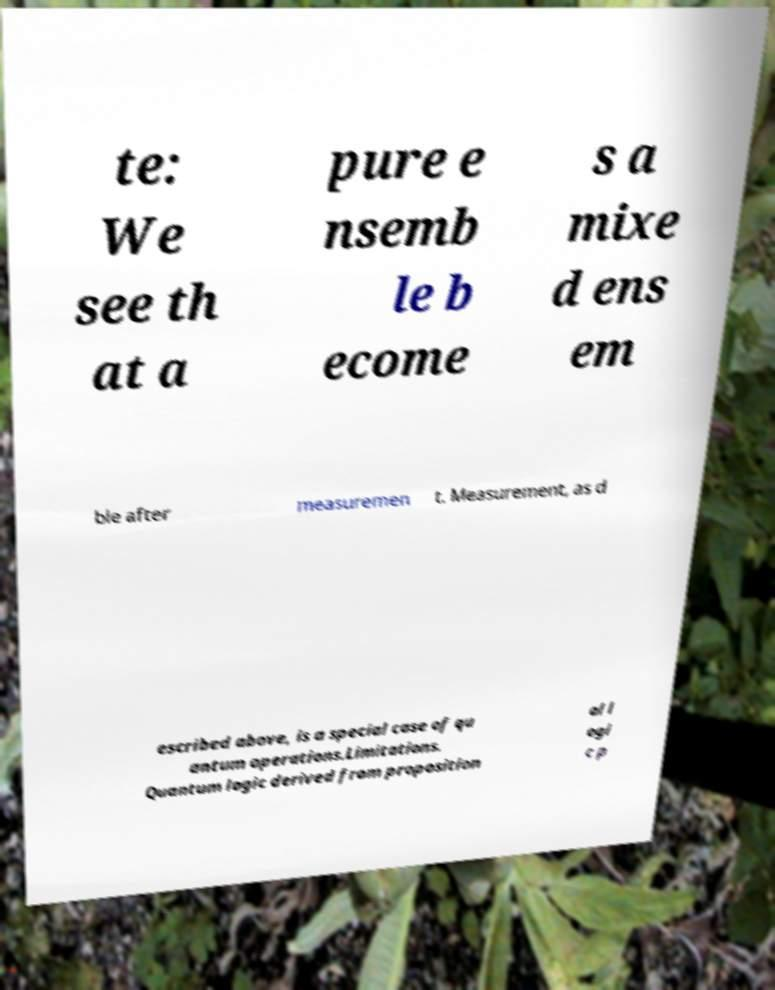Could you extract and type out the text from this image? te: We see th at a pure e nsemb le b ecome s a mixe d ens em ble after measuremen t. Measurement, as d escribed above, is a special case of qu antum operations.Limitations. Quantum logic derived from proposition al l ogi c p 